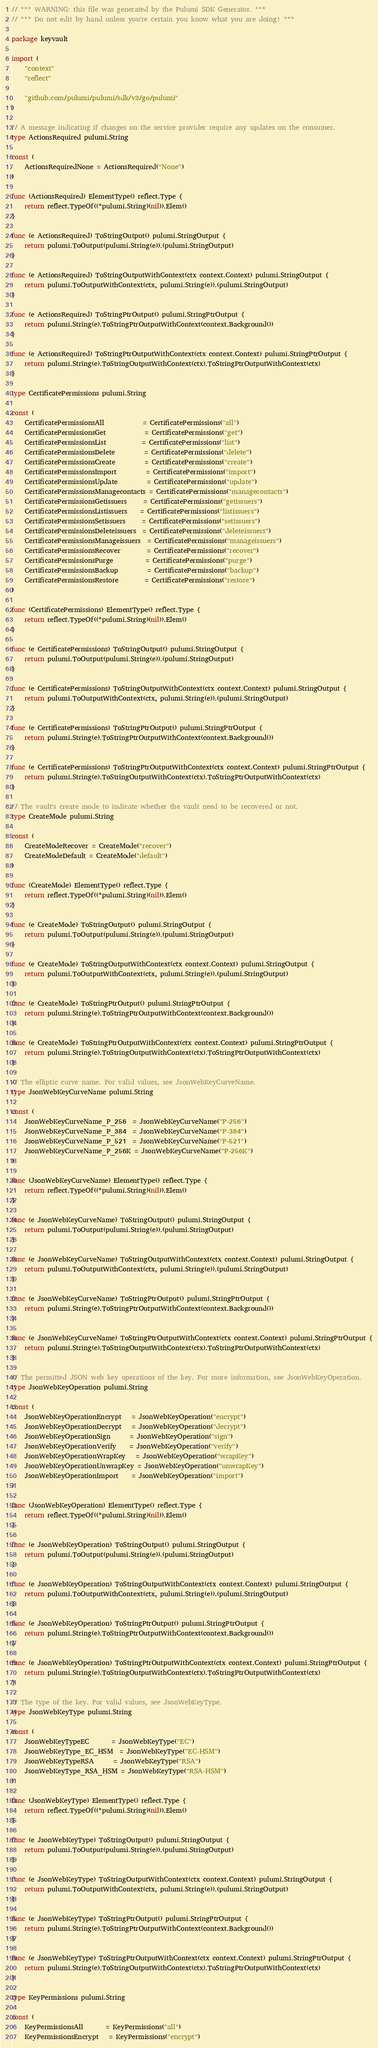Convert code to text. <code><loc_0><loc_0><loc_500><loc_500><_Go_>// *** WARNING: this file was generated by the Pulumi SDK Generator. ***
// *** Do not edit by hand unless you're certain you know what you are doing! ***

package keyvault

import (
	"context"
	"reflect"

	"github.com/pulumi/pulumi/sdk/v3/go/pulumi"
)

// A message indicating if changes on the service provider require any updates on the consumer.
type ActionsRequired pulumi.String

const (
	ActionsRequiredNone = ActionsRequired("None")
)

func (ActionsRequired) ElementType() reflect.Type {
	return reflect.TypeOf((*pulumi.String)(nil)).Elem()
}

func (e ActionsRequired) ToStringOutput() pulumi.StringOutput {
	return pulumi.ToOutput(pulumi.String(e)).(pulumi.StringOutput)
}

func (e ActionsRequired) ToStringOutputWithContext(ctx context.Context) pulumi.StringOutput {
	return pulumi.ToOutputWithContext(ctx, pulumi.String(e)).(pulumi.StringOutput)
}

func (e ActionsRequired) ToStringPtrOutput() pulumi.StringPtrOutput {
	return pulumi.String(e).ToStringPtrOutputWithContext(context.Background())
}

func (e ActionsRequired) ToStringPtrOutputWithContext(ctx context.Context) pulumi.StringPtrOutput {
	return pulumi.String(e).ToStringOutputWithContext(ctx).ToStringPtrOutputWithContext(ctx)
}

type CertificatePermissions pulumi.String

const (
	CertificatePermissionsAll            = CertificatePermissions("all")
	CertificatePermissionsGet            = CertificatePermissions("get")
	CertificatePermissionsList           = CertificatePermissions("list")
	CertificatePermissionsDelete         = CertificatePermissions("delete")
	CertificatePermissionsCreate         = CertificatePermissions("create")
	CertificatePermissionsImport         = CertificatePermissions("import")
	CertificatePermissionsUpdate         = CertificatePermissions("update")
	CertificatePermissionsManagecontacts = CertificatePermissions("managecontacts")
	CertificatePermissionsGetissuers     = CertificatePermissions("getissuers")
	CertificatePermissionsListissuers    = CertificatePermissions("listissuers")
	CertificatePermissionsSetissuers     = CertificatePermissions("setissuers")
	CertificatePermissionsDeleteissuers  = CertificatePermissions("deleteissuers")
	CertificatePermissionsManageissuers  = CertificatePermissions("manageissuers")
	CertificatePermissionsRecover        = CertificatePermissions("recover")
	CertificatePermissionsPurge          = CertificatePermissions("purge")
	CertificatePermissionsBackup         = CertificatePermissions("backup")
	CertificatePermissionsRestore        = CertificatePermissions("restore")
)

func (CertificatePermissions) ElementType() reflect.Type {
	return reflect.TypeOf((*pulumi.String)(nil)).Elem()
}

func (e CertificatePermissions) ToStringOutput() pulumi.StringOutput {
	return pulumi.ToOutput(pulumi.String(e)).(pulumi.StringOutput)
}

func (e CertificatePermissions) ToStringOutputWithContext(ctx context.Context) pulumi.StringOutput {
	return pulumi.ToOutputWithContext(ctx, pulumi.String(e)).(pulumi.StringOutput)
}

func (e CertificatePermissions) ToStringPtrOutput() pulumi.StringPtrOutput {
	return pulumi.String(e).ToStringPtrOutputWithContext(context.Background())
}

func (e CertificatePermissions) ToStringPtrOutputWithContext(ctx context.Context) pulumi.StringPtrOutput {
	return pulumi.String(e).ToStringOutputWithContext(ctx).ToStringPtrOutputWithContext(ctx)
}

// The vault's create mode to indicate whether the vault need to be recovered or not.
type CreateMode pulumi.String

const (
	CreateModeRecover = CreateMode("recover")
	CreateModeDefault = CreateMode("default")
)

func (CreateMode) ElementType() reflect.Type {
	return reflect.TypeOf((*pulumi.String)(nil)).Elem()
}

func (e CreateMode) ToStringOutput() pulumi.StringOutput {
	return pulumi.ToOutput(pulumi.String(e)).(pulumi.StringOutput)
}

func (e CreateMode) ToStringOutputWithContext(ctx context.Context) pulumi.StringOutput {
	return pulumi.ToOutputWithContext(ctx, pulumi.String(e)).(pulumi.StringOutput)
}

func (e CreateMode) ToStringPtrOutput() pulumi.StringPtrOutput {
	return pulumi.String(e).ToStringPtrOutputWithContext(context.Background())
}

func (e CreateMode) ToStringPtrOutputWithContext(ctx context.Context) pulumi.StringPtrOutput {
	return pulumi.String(e).ToStringOutputWithContext(ctx).ToStringPtrOutputWithContext(ctx)
}

// The elliptic curve name. For valid values, see JsonWebKeyCurveName.
type JsonWebKeyCurveName pulumi.String

const (
	JsonWebKeyCurveName_P_256  = JsonWebKeyCurveName("P-256")
	JsonWebKeyCurveName_P_384  = JsonWebKeyCurveName("P-384")
	JsonWebKeyCurveName_P_521  = JsonWebKeyCurveName("P-521")
	JsonWebKeyCurveName_P_256K = JsonWebKeyCurveName("P-256K")
)

func (JsonWebKeyCurveName) ElementType() reflect.Type {
	return reflect.TypeOf((*pulumi.String)(nil)).Elem()
}

func (e JsonWebKeyCurveName) ToStringOutput() pulumi.StringOutput {
	return pulumi.ToOutput(pulumi.String(e)).(pulumi.StringOutput)
}

func (e JsonWebKeyCurveName) ToStringOutputWithContext(ctx context.Context) pulumi.StringOutput {
	return pulumi.ToOutputWithContext(ctx, pulumi.String(e)).(pulumi.StringOutput)
}

func (e JsonWebKeyCurveName) ToStringPtrOutput() pulumi.StringPtrOutput {
	return pulumi.String(e).ToStringPtrOutputWithContext(context.Background())
}

func (e JsonWebKeyCurveName) ToStringPtrOutputWithContext(ctx context.Context) pulumi.StringPtrOutput {
	return pulumi.String(e).ToStringOutputWithContext(ctx).ToStringPtrOutputWithContext(ctx)
}

// The permitted JSON web key operations of the key. For more information, see JsonWebKeyOperation.
type JsonWebKeyOperation pulumi.String

const (
	JsonWebKeyOperationEncrypt   = JsonWebKeyOperation("encrypt")
	JsonWebKeyOperationDecrypt   = JsonWebKeyOperation("decrypt")
	JsonWebKeyOperationSign      = JsonWebKeyOperation("sign")
	JsonWebKeyOperationVerify    = JsonWebKeyOperation("verify")
	JsonWebKeyOperationWrapKey   = JsonWebKeyOperation("wrapKey")
	JsonWebKeyOperationUnwrapKey = JsonWebKeyOperation("unwrapKey")
	JsonWebKeyOperationImport    = JsonWebKeyOperation("import")
)

func (JsonWebKeyOperation) ElementType() reflect.Type {
	return reflect.TypeOf((*pulumi.String)(nil)).Elem()
}

func (e JsonWebKeyOperation) ToStringOutput() pulumi.StringOutput {
	return pulumi.ToOutput(pulumi.String(e)).(pulumi.StringOutput)
}

func (e JsonWebKeyOperation) ToStringOutputWithContext(ctx context.Context) pulumi.StringOutput {
	return pulumi.ToOutputWithContext(ctx, pulumi.String(e)).(pulumi.StringOutput)
}

func (e JsonWebKeyOperation) ToStringPtrOutput() pulumi.StringPtrOutput {
	return pulumi.String(e).ToStringPtrOutputWithContext(context.Background())
}

func (e JsonWebKeyOperation) ToStringPtrOutputWithContext(ctx context.Context) pulumi.StringPtrOutput {
	return pulumi.String(e).ToStringOutputWithContext(ctx).ToStringPtrOutputWithContext(ctx)
}

// The type of the key. For valid values, see JsonWebKeyType.
type JsonWebKeyType pulumi.String

const (
	JsonWebKeyTypeEC       = JsonWebKeyType("EC")
	JsonWebKeyType_EC_HSM  = JsonWebKeyType("EC-HSM")
	JsonWebKeyTypeRSA      = JsonWebKeyType("RSA")
	JsonWebKeyType_RSA_HSM = JsonWebKeyType("RSA-HSM")
)

func (JsonWebKeyType) ElementType() reflect.Type {
	return reflect.TypeOf((*pulumi.String)(nil)).Elem()
}

func (e JsonWebKeyType) ToStringOutput() pulumi.StringOutput {
	return pulumi.ToOutput(pulumi.String(e)).(pulumi.StringOutput)
}

func (e JsonWebKeyType) ToStringOutputWithContext(ctx context.Context) pulumi.StringOutput {
	return pulumi.ToOutputWithContext(ctx, pulumi.String(e)).(pulumi.StringOutput)
}

func (e JsonWebKeyType) ToStringPtrOutput() pulumi.StringPtrOutput {
	return pulumi.String(e).ToStringPtrOutputWithContext(context.Background())
}

func (e JsonWebKeyType) ToStringPtrOutputWithContext(ctx context.Context) pulumi.StringPtrOutput {
	return pulumi.String(e).ToStringOutputWithContext(ctx).ToStringPtrOutputWithContext(ctx)
}

type KeyPermissions pulumi.String

const (
	KeyPermissionsAll       = KeyPermissions("all")
	KeyPermissionsEncrypt   = KeyPermissions("encrypt")</code> 